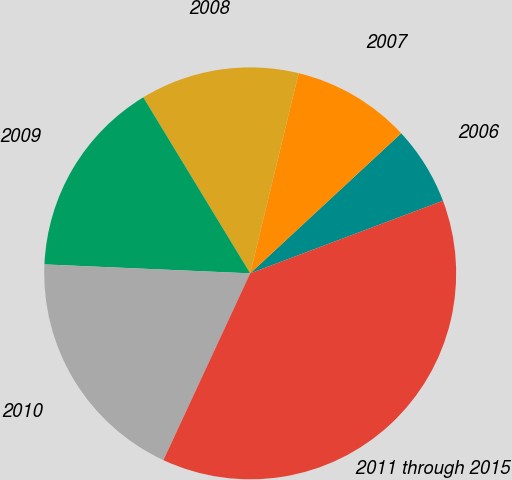<chart> <loc_0><loc_0><loc_500><loc_500><pie_chart><fcel>2006<fcel>2007<fcel>2008<fcel>2009<fcel>2010<fcel>2011 through 2015<nl><fcel>6.17%<fcel>9.32%<fcel>12.47%<fcel>15.62%<fcel>18.77%<fcel>37.66%<nl></chart> 